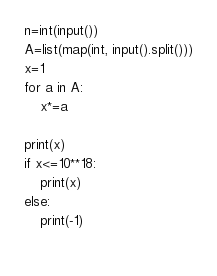Convert code to text. <code><loc_0><loc_0><loc_500><loc_500><_Python_>n=int(input())
A=list(map(int, input().split()))
x=1
for a in A:
    x*=a

print(x)
if x<=10**18:
    print(x)
else:
    print(-1)
    </code> 